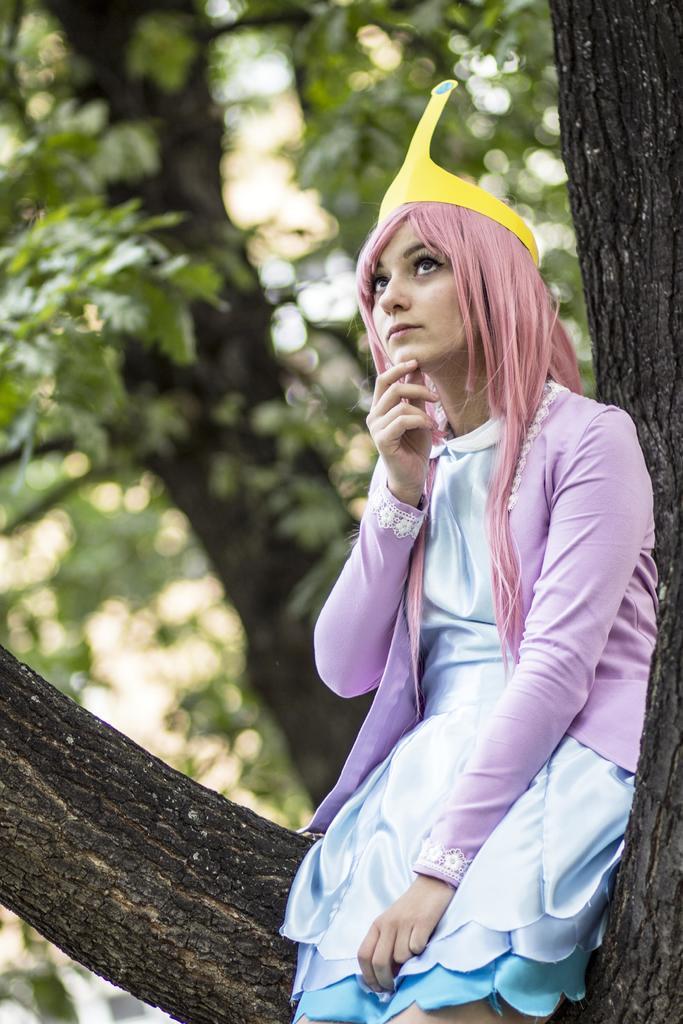How would you summarize this image in a sentence or two? In this image there is a girl sitting on the tree by wearing the yellow colour cap and pink colour top. In the background there is a tree with the green leaves. 